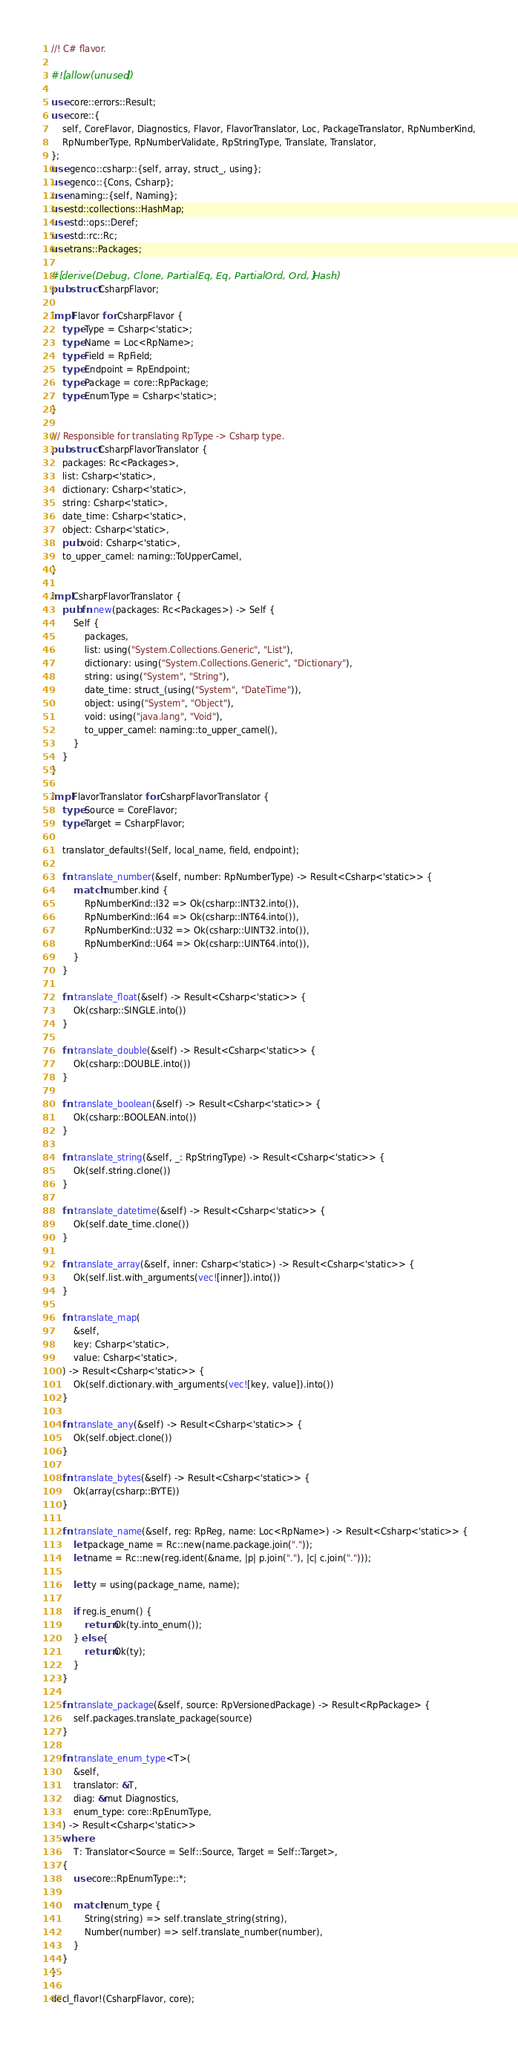<code> <loc_0><loc_0><loc_500><loc_500><_Rust_>//! C# flavor.

#![allow(unused)]

use core::errors::Result;
use core::{
    self, CoreFlavor, Diagnostics, Flavor, FlavorTranslator, Loc, PackageTranslator, RpNumberKind,
    RpNumberType, RpNumberValidate, RpStringType, Translate, Translator,
};
use genco::csharp::{self, array, struct_, using};
use genco::{Cons, Csharp};
use naming::{self, Naming};
use std::collections::HashMap;
use std::ops::Deref;
use std::rc::Rc;
use trans::Packages;

#[derive(Debug, Clone, PartialEq, Eq, PartialOrd, Ord, Hash)]
pub struct CsharpFlavor;

impl Flavor for CsharpFlavor {
    type Type = Csharp<'static>;
    type Name = Loc<RpName>;
    type Field = RpField;
    type Endpoint = RpEndpoint;
    type Package = core::RpPackage;
    type EnumType = Csharp<'static>;
}

/// Responsible for translating RpType -> Csharp type.
pub struct CsharpFlavorTranslator {
    packages: Rc<Packages>,
    list: Csharp<'static>,
    dictionary: Csharp<'static>,
    string: Csharp<'static>,
    date_time: Csharp<'static>,
    object: Csharp<'static>,
    pub void: Csharp<'static>,
    to_upper_camel: naming::ToUpperCamel,
}

impl CsharpFlavorTranslator {
    pub fn new(packages: Rc<Packages>) -> Self {
        Self {
            packages,
            list: using("System.Collections.Generic", "List"),
            dictionary: using("System.Collections.Generic", "Dictionary"),
            string: using("System", "String"),
            date_time: struct_(using("System", "DateTime")),
            object: using("System", "Object"),
            void: using("java.lang", "Void"),
            to_upper_camel: naming::to_upper_camel(),
        }
    }
}

impl FlavorTranslator for CsharpFlavorTranslator {
    type Source = CoreFlavor;
    type Target = CsharpFlavor;

    translator_defaults!(Self, local_name, field, endpoint);

    fn translate_number(&self, number: RpNumberType) -> Result<Csharp<'static>> {
        match number.kind {
            RpNumberKind::I32 => Ok(csharp::INT32.into()),
            RpNumberKind::I64 => Ok(csharp::INT64.into()),
            RpNumberKind::U32 => Ok(csharp::UINT32.into()),
            RpNumberKind::U64 => Ok(csharp::UINT64.into()),
        }
    }

    fn translate_float(&self) -> Result<Csharp<'static>> {
        Ok(csharp::SINGLE.into())
    }

    fn translate_double(&self) -> Result<Csharp<'static>> {
        Ok(csharp::DOUBLE.into())
    }

    fn translate_boolean(&self) -> Result<Csharp<'static>> {
        Ok(csharp::BOOLEAN.into())
    }

    fn translate_string(&self, _: RpStringType) -> Result<Csharp<'static>> {
        Ok(self.string.clone())
    }

    fn translate_datetime(&self) -> Result<Csharp<'static>> {
        Ok(self.date_time.clone())
    }

    fn translate_array(&self, inner: Csharp<'static>) -> Result<Csharp<'static>> {
        Ok(self.list.with_arguments(vec![inner]).into())
    }

    fn translate_map(
        &self,
        key: Csharp<'static>,
        value: Csharp<'static>,
    ) -> Result<Csharp<'static>> {
        Ok(self.dictionary.with_arguments(vec![key, value]).into())
    }

    fn translate_any(&self) -> Result<Csharp<'static>> {
        Ok(self.object.clone())
    }

    fn translate_bytes(&self) -> Result<Csharp<'static>> {
        Ok(array(csharp::BYTE))
    }

    fn translate_name(&self, reg: RpReg, name: Loc<RpName>) -> Result<Csharp<'static>> {
        let package_name = Rc::new(name.package.join("."));
        let name = Rc::new(reg.ident(&name, |p| p.join("."), |c| c.join(".")));

        let ty = using(package_name, name);

        if reg.is_enum() {
            return Ok(ty.into_enum());
        } else {
            return Ok(ty);
        }
    }

    fn translate_package(&self, source: RpVersionedPackage) -> Result<RpPackage> {
        self.packages.translate_package(source)
    }

    fn translate_enum_type<T>(
        &self,
        translator: &T,
        diag: &mut Diagnostics,
        enum_type: core::RpEnumType,
    ) -> Result<Csharp<'static>>
    where
        T: Translator<Source = Self::Source, Target = Self::Target>,
    {
        use core::RpEnumType::*;

        match enum_type {
            String(string) => self.translate_string(string),
            Number(number) => self.translate_number(number),
        }
    }
}

decl_flavor!(CsharpFlavor, core);
</code> 